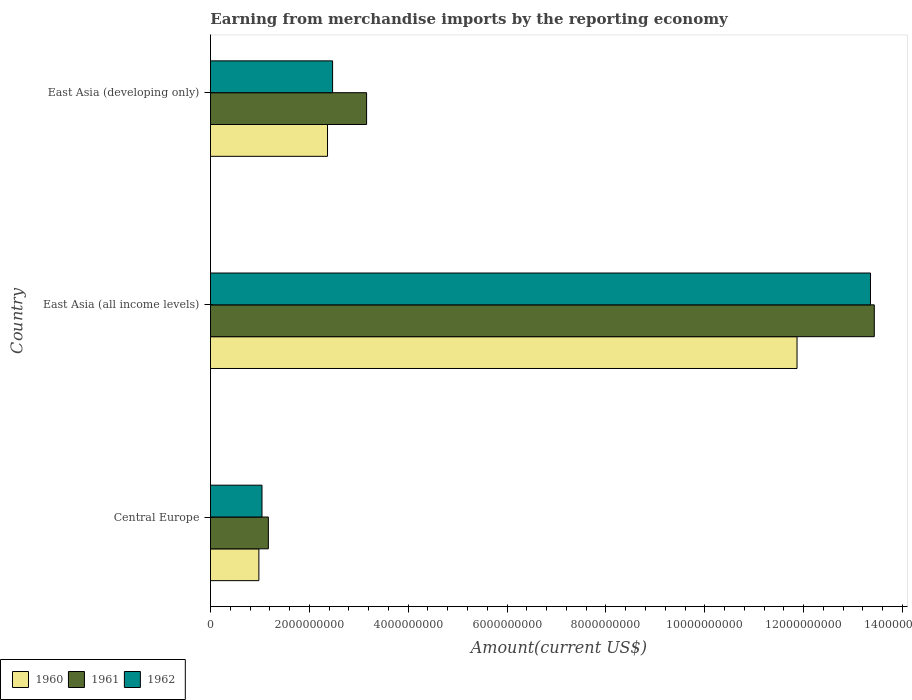How many different coloured bars are there?
Keep it short and to the point. 3. What is the label of the 3rd group of bars from the top?
Provide a short and direct response. Central Europe. In how many cases, is the number of bars for a given country not equal to the number of legend labels?
Offer a terse response. 0. What is the amount earned from merchandise imports in 1961 in East Asia (all income levels)?
Give a very brief answer. 1.34e+1. Across all countries, what is the maximum amount earned from merchandise imports in 1960?
Make the answer very short. 1.19e+1. Across all countries, what is the minimum amount earned from merchandise imports in 1961?
Provide a succinct answer. 1.17e+09. In which country was the amount earned from merchandise imports in 1960 maximum?
Provide a succinct answer. East Asia (all income levels). In which country was the amount earned from merchandise imports in 1962 minimum?
Your answer should be very brief. Central Europe. What is the total amount earned from merchandise imports in 1960 in the graph?
Make the answer very short. 1.52e+1. What is the difference between the amount earned from merchandise imports in 1960 in Central Europe and that in East Asia (developing only)?
Offer a terse response. -1.39e+09. What is the difference between the amount earned from merchandise imports in 1960 in East Asia (all income levels) and the amount earned from merchandise imports in 1961 in East Asia (developing only)?
Your answer should be compact. 8.71e+09. What is the average amount earned from merchandise imports in 1961 per country?
Your answer should be compact. 5.92e+09. What is the difference between the amount earned from merchandise imports in 1961 and amount earned from merchandise imports in 1960 in Central Europe?
Offer a terse response. 1.92e+08. In how many countries, is the amount earned from merchandise imports in 1961 greater than 800000000 US$?
Your answer should be compact. 3. What is the ratio of the amount earned from merchandise imports in 1961 in East Asia (all income levels) to that in East Asia (developing only)?
Keep it short and to the point. 4.25. Is the amount earned from merchandise imports in 1961 in Central Europe less than that in East Asia (all income levels)?
Offer a terse response. Yes. What is the difference between the highest and the second highest amount earned from merchandise imports in 1962?
Your response must be concise. 1.09e+1. What is the difference between the highest and the lowest amount earned from merchandise imports in 1960?
Ensure brevity in your answer.  1.09e+1. How many bars are there?
Your answer should be compact. 9. Are all the bars in the graph horizontal?
Keep it short and to the point. Yes. Does the graph contain any zero values?
Provide a succinct answer. No. Does the graph contain grids?
Your response must be concise. No. How many legend labels are there?
Keep it short and to the point. 3. What is the title of the graph?
Ensure brevity in your answer.  Earning from merchandise imports by the reporting economy. What is the label or title of the X-axis?
Keep it short and to the point. Amount(current US$). What is the label or title of the Y-axis?
Your answer should be very brief. Country. What is the Amount(current US$) in 1960 in Central Europe?
Provide a succinct answer. 9.79e+08. What is the Amount(current US$) in 1961 in Central Europe?
Offer a very short reply. 1.17e+09. What is the Amount(current US$) in 1962 in Central Europe?
Your answer should be very brief. 1.04e+09. What is the Amount(current US$) of 1960 in East Asia (all income levels)?
Provide a succinct answer. 1.19e+1. What is the Amount(current US$) in 1961 in East Asia (all income levels)?
Keep it short and to the point. 1.34e+1. What is the Amount(current US$) in 1962 in East Asia (all income levels)?
Offer a very short reply. 1.34e+1. What is the Amount(current US$) of 1960 in East Asia (developing only)?
Ensure brevity in your answer.  2.37e+09. What is the Amount(current US$) of 1961 in East Asia (developing only)?
Give a very brief answer. 3.16e+09. What is the Amount(current US$) of 1962 in East Asia (developing only)?
Give a very brief answer. 2.47e+09. Across all countries, what is the maximum Amount(current US$) in 1960?
Your answer should be very brief. 1.19e+1. Across all countries, what is the maximum Amount(current US$) of 1961?
Provide a short and direct response. 1.34e+1. Across all countries, what is the maximum Amount(current US$) of 1962?
Ensure brevity in your answer.  1.34e+1. Across all countries, what is the minimum Amount(current US$) in 1960?
Your answer should be very brief. 9.79e+08. Across all countries, what is the minimum Amount(current US$) in 1961?
Keep it short and to the point. 1.17e+09. Across all countries, what is the minimum Amount(current US$) of 1962?
Offer a terse response. 1.04e+09. What is the total Amount(current US$) in 1960 in the graph?
Offer a very short reply. 1.52e+1. What is the total Amount(current US$) in 1961 in the graph?
Offer a very short reply. 1.78e+1. What is the total Amount(current US$) of 1962 in the graph?
Your answer should be very brief. 1.69e+1. What is the difference between the Amount(current US$) in 1960 in Central Europe and that in East Asia (all income levels)?
Offer a very short reply. -1.09e+1. What is the difference between the Amount(current US$) in 1961 in Central Europe and that in East Asia (all income levels)?
Your answer should be compact. -1.23e+1. What is the difference between the Amount(current US$) in 1962 in Central Europe and that in East Asia (all income levels)?
Offer a terse response. -1.23e+1. What is the difference between the Amount(current US$) in 1960 in Central Europe and that in East Asia (developing only)?
Your answer should be compact. -1.39e+09. What is the difference between the Amount(current US$) of 1961 in Central Europe and that in East Asia (developing only)?
Ensure brevity in your answer.  -1.99e+09. What is the difference between the Amount(current US$) of 1962 in Central Europe and that in East Asia (developing only)?
Offer a terse response. -1.43e+09. What is the difference between the Amount(current US$) in 1960 in East Asia (all income levels) and that in East Asia (developing only)?
Offer a terse response. 9.50e+09. What is the difference between the Amount(current US$) in 1961 in East Asia (all income levels) and that in East Asia (developing only)?
Your answer should be compact. 1.03e+1. What is the difference between the Amount(current US$) of 1962 in East Asia (all income levels) and that in East Asia (developing only)?
Your answer should be very brief. 1.09e+1. What is the difference between the Amount(current US$) of 1960 in Central Europe and the Amount(current US$) of 1961 in East Asia (all income levels)?
Your answer should be very brief. -1.24e+1. What is the difference between the Amount(current US$) of 1960 in Central Europe and the Amount(current US$) of 1962 in East Asia (all income levels)?
Your answer should be compact. -1.24e+1. What is the difference between the Amount(current US$) in 1961 in Central Europe and the Amount(current US$) in 1962 in East Asia (all income levels)?
Offer a terse response. -1.22e+1. What is the difference between the Amount(current US$) of 1960 in Central Europe and the Amount(current US$) of 1961 in East Asia (developing only)?
Your answer should be very brief. -2.18e+09. What is the difference between the Amount(current US$) in 1960 in Central Europe and the Amount(current US$) in 1962 in East Asia (developing only)?
Offer a terse response. -1.49e+09. What is the difference between the Amount(current US$) of 1961 in Central Europe and the Amount(current US$) of 1962 in East Asia (developing only)?
Keep it short and to the point. -1.30e+09. What is the difference between the Amount(current US$) in 1960 in East Asia (all income levels) and the Amount(current US$) in 1961 in East Asia (developing only)?
Your response must be concise. 8.71e+09. What is the difference between the Amount(current US$) in 1960 in East Asia (all income levels) and the Amount(current US$) in 1962 in East Asia (developing only)?
Provide a short and direct response. 9.40e+09. What is the difference between the Amount(current US$) of 1961 in East Asia (all income levels) and the Amount(current US$) of 1962 in East Asia (developing only)?
Your answer should be compact. 1.10e+1. What is the average Amount(current US$) of 1960 per country?
Ensure brevity in your answer.  5.07e+09. What is the average Amount(current US$) of 1961 per country?
Offer a very short reply. 5.92e+09. What is the average Amount(current US$) of 1962 per country?
Your answer should be very brief. 5.62e+09. What is the difference between the Amount(current US$) in 1960 and Amount(current US$) in 1961 in Central Europe?
Give a very brief answer. -1.92e+08. What is the difference between the Amount(current US$) in 1960 and Amount(current US$) in 1962 in Central Europe?
Your response must be concise. -6.33e+07. What is the difference between the Amount(current US$) in 1961 and Amount(current US$) in 1962 in Central Europe?
Give a very brief answer. 1.28e+08. What is the difference between the Amount(current US$) in 1960 and Amount(current US$) in 1961 in East Asia (all income levels)?
Offer a very short reply. -1.56e+09. What is the difference between the Amount(current US$) in 1960 and Amount(current US$) in 1962 in East Asia (all income levels)?
Ensure brevity in your answer.  -1.49e+09. What is the difference between the Amount(current US$) of 1961 and Amount(current US$) of 1962 in East Asia (all income levels)?
Your answer should be very brief. 7.72e+07. What is the difference between the Amount(current US$) of 1960 and Amount(current US$) of 1961 in East Asia (developing only)?
Keep it short and to the point. -7.90e+08. What is the difference between the Amount(current US$) in 1960 and Amount(current US$) in 1962 in East Asia (developing only)?
Offer a very short reply. -1.03e+08. What is the difference between the Amount(current US$) of 1961 and Amount(current US$) of 1962 in East Asia (developing only)?
Your answer should be very brief. 6.88e+08. What is the ratio of the Amount(current US$) in 1960 in Central Europe to that in East Asia (all income levels)?
Your response must be concise. 0.08. What is the ratio of the Amount(current US$) in 1961 in Central Europe to that in East Asia (all income levels)?
Give a very brief answer. 0.09. What is the ratio of the Amount(current US$) in 1962 in Central Europe to that in East Asia (all income levels)?
Offer a very short reply. 0.08. What is the ratio of the Amount(current US$) in 1960 in Central Europe to that in East Asia (developing only)?
Make the answer very short. 0.41. What is the ratio of the Amount(current US$) in 1961 in Central Europe to that in East Asia (developing only)?
Your response must be concise. 0.37. What is the ratio of the Amount(current US$) in 1962 in Central Europe to that in East Asia (developing only)?
Your response must be concise. 0.42. What is the ratio of the Amount(current US$) of 1960 in East Asia (all income levels) to that in East Asia (developing only)?
Your response must be concise. 5.01. What is the ratio of the Amount(current US$) in 1961 in East Asia (all income levels) to that in East Asia (developing only)?
Make the answer very short. 4.25. What is the ratio of the Amount(current US$) of 1962 in East Asia (all income levels) to that in East Asia (developing only)?
Keep it short and to the point. 5.4. What is the difference between the highest and the second highest Amount(current US$) of 1960?
Your response must be concise. 9.50e+09. What is the difference between the highest and the second highest Amount(current US$) in 1961?
Ensure brevity in your answer.  1.03e+1. What is the difference between the highest and the second highest Amount(current US$) of 1962?
Provide a short and direct response. 1.09e+1. What is the difference between the highest and the lowest Amount(current US$) in 1960?
Keep it short and to the point. 1.09e+1. What is the difference between the highest and the lowest Amount(current US$) of 1961?
Your answer should be compact. 1.23e+1. What is the difference between the highest and the lowest Amount(current US$) in 1962?
Your response must be concise. 1.23e+1. 